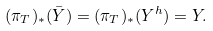<formula> <loc_0><loc_0><loc_500><loc_500>( \pi _ { T } ) _ { * } ( \bar { Y } ) = ( \pi _ { T } ) _ { * } ( Y ^ { h } ) = Y .</formula> 